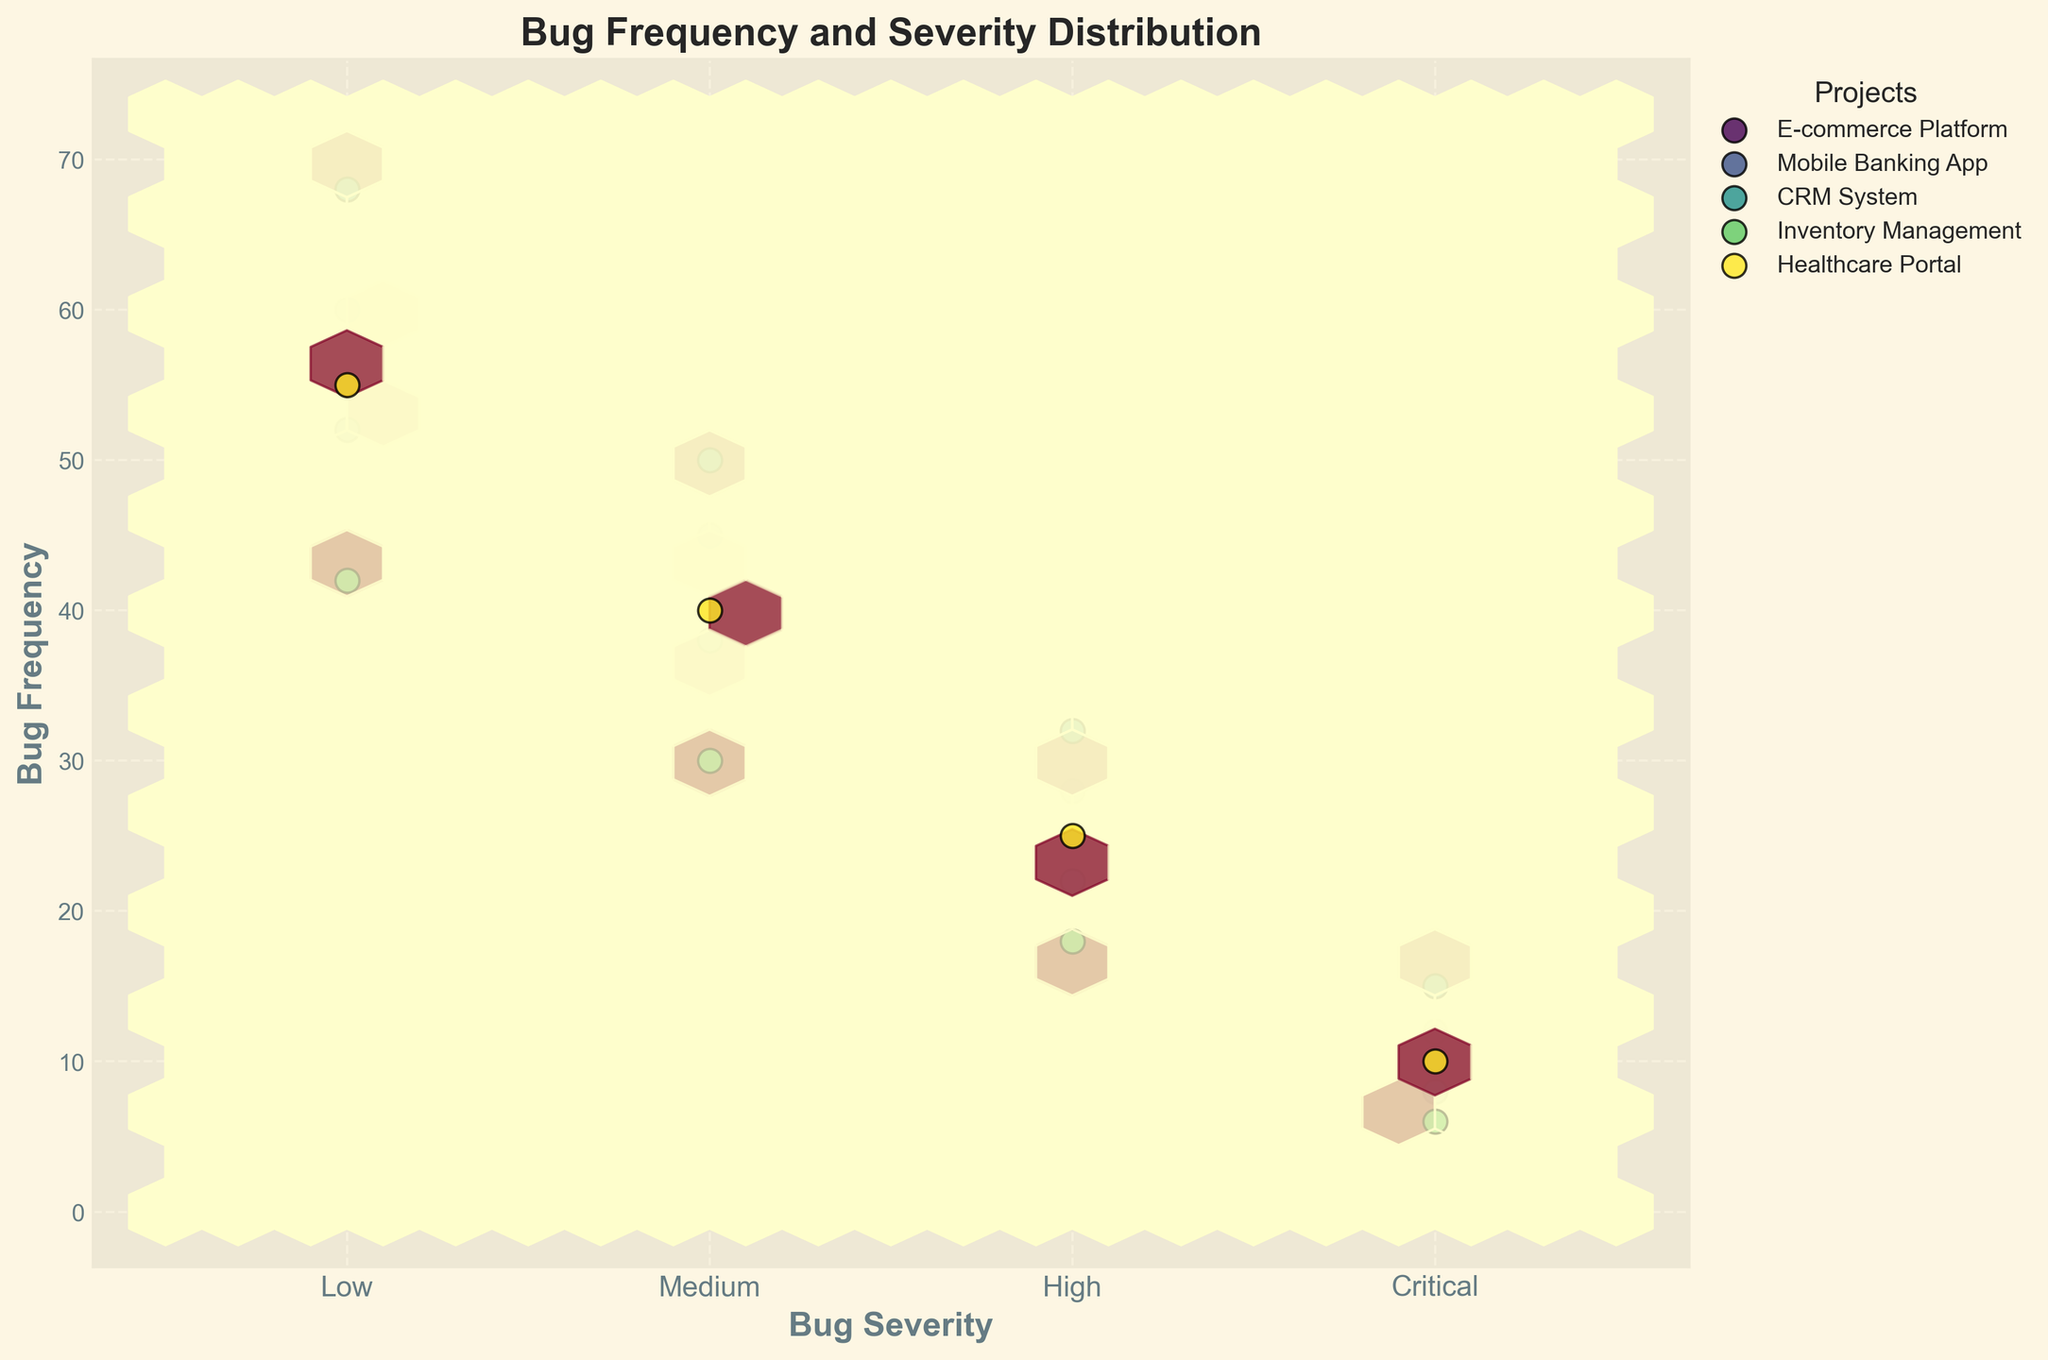How many different bug severity levels are represented in the plot? By looking at the x-axis and the labeled categories, we can see there are four different bug severity levels indicated: Low, Medium, High, and Critical
Answer: 4 What is the title of the plot? The title of the plot is written at the top and reads: 'Bug Frequency and Severity Distribution'
Answer: Bug Frequency and Severity Distribution Which project has the highest frequency of Critical severity bugs? To find this, look at the hexbin and scatter points on the rightmost side of the x-axis labeled 'Critical'. The project with the highest y-axis value is the CRM System with a frequency of 15
Answer: CRM System Which severity level has the lowest average frequency across all projects? First, observe the y-values for each severity level (Low, Medium, High, Critical), then calculate the average for each: 
Low: (60+52+68+42+55)/5=55.4, 
Medium: (45+38+50+30+40)/5=40.6, 
High: (28+22+32+18+25)/5=25, 
Critical: (12+8+15+6+10)/5=10.2. 
The lowest average is for Critical
Answer: Critical Does the Inventory Management project have more High severity bugs than the E-commerce Platform? By comparing points labeled 'High' for each project, we see that Inventory Management has a frequency of 18 and E-commerce Platform has a frequency of 28. Thus, E-commerce Platform has more High severity bugs
Answer: No What color represents the Healthcare Portal project in the plot? The legend on the right side defines each project's color. Healthcare Portal is represented by a specific color marked in the legend corresponding to its position.
Answer: Color identified by the legend for Healthcare Portal For which severity level do all projects collectively have the highest frequency? By summing the y-values for each severity level across all projects: 
Low: 60+52+68+42+55=277, 
Medium: 45+38+50+30+40=203, 
High: 28+22+32+18+25=125, 
Critical: 12+8+15+6+10=51. 
The highest frequency is for Low
Answer: Low What is the grid size used in the hexbin plot? The grid size used for hexbin plots affects the number and size of the hexagons. The provided code shows the grid size is set to 20
Answer: 20 Is there a project with a higher frequency of Low severity bugs than Medium severity bugs? Compare the points for 'Low' and 'Medium' severity levels for each project. All projects, i.e., E-commerce Platform, Mobile Banking App, CRM System, Inventory Management, and Healthcare Portal, show higher frequencies for Low severity bugs than Medium severity bugs
Answer: Yes 